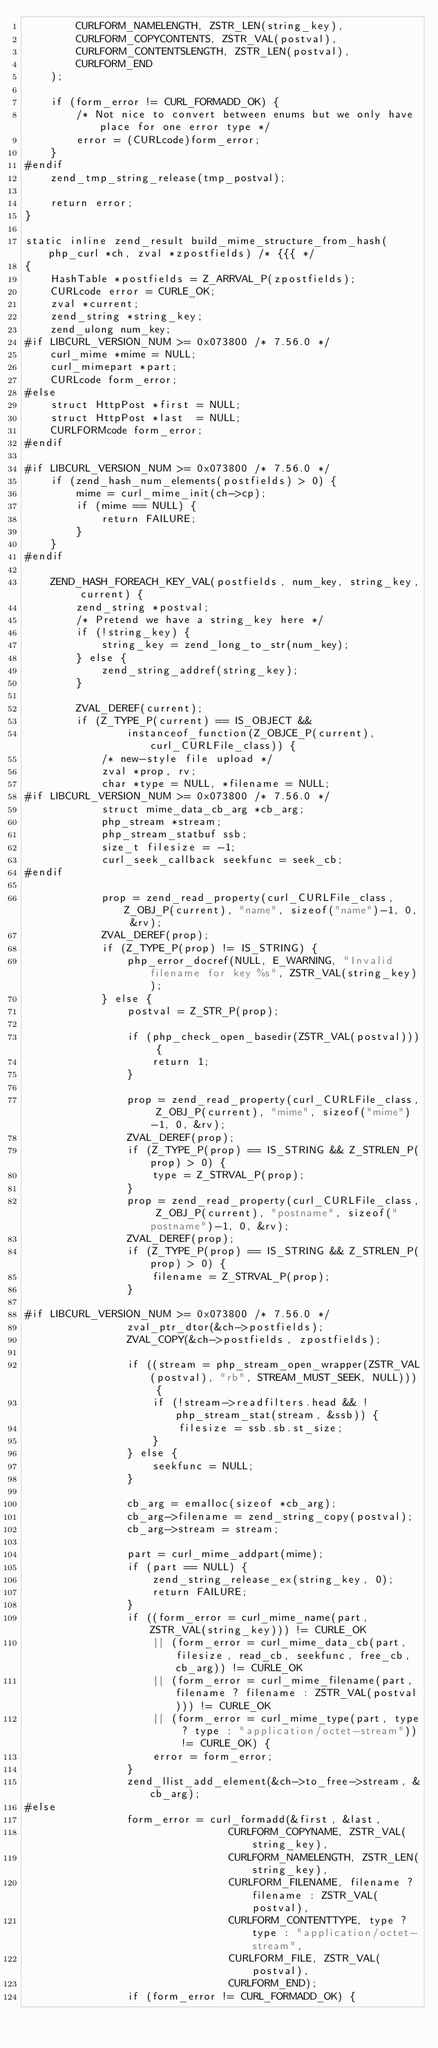<code> <loc_0><loc_0><loc_500><loc_500><_C_>		CURLFORM_NAMELENGTH, ZSTR_LEN(string_key),
		CURLFORM_COPYCONTENTS, ZSTR_VAL(postval),
		CURLFORM_CONTENTSLENGTH, ZSTR_LEN(postval),
		CURLFORM_END
	);

	if (form_error != CURL_FORMADD_OK) {
		/* Not nice to convert between enums but we only have place for one error type */
		error = (CURLcode)form_error;
	}
#endif
	zend_tmp_string_release(tmp_postval);

	return error;
}

static inline zend_result build_mime_structure_from_hash(php_curl *ch, zval *zpostfields) /* {{{ */
{
	HashTable *postfields = Z_ARRVAL_P(zpostfields);
	CURLcode error = CURLE_OK;
	zval *current;
	zend_string *string_key;
	zend_ulong num_key;
#if LIBCURL_VERSION_NUM >= 0x073800 /* 7.56.0 */
	curl_mime *mime = NULL;
	curl_mimepart *part;
	CURLcode form_error;
#else
	struct HttpPost *first = NULL;
	struct HttpPost *last  = NULL;
	CURLFORMcode form_error;
#endif

#if LIBCURL_VERSION_NUM >= 0x073800 /* 7.56.0 */
	if (zend_hash_num_elements(postfields) > 0) {
		mime = curl_mime_init(ch->cp);
		if (mime == NULL) {
			return FAILURE;
		}
	}
#endif

	ZEND_HASH_FOREACH_KEY_VAL(postfields, num_key, string_key, current) {
		zend_string *postval;
		/* Pretend we have a string_key here */
		if (!string_key) {
			string_key = zend_long_to_str(num_key);
		} else {
			zend_string_addref(string_key);
		}

		ZVAL_DEREF(current);
		if (Z_TYPE_P(current) == IS_OBJECT &&
				instanceof_function(Z_OBJCE_P(current), curl_CURLFile_class)) {
			/* new-style file upload */
			zval *prop, rv;
			char *type = NULL, *filename = NULL;
#if LIBCURL_VERSION_NUM >= 0x073800 /* 7.56.0 */
			struct mime_data_cb_arg *cb_arg;
			php_stream *stream;
			php_stream_statbuf ssb;
			size_t filesize = -1;
			curl_seek_callback seekfunc = seek_cb;
#endif

			prop = zend_read_property(curl_CURLFile_class, Z_OBJ_P(current), "name", sizeof("name")-1, 0, &rv);
			ZVAL_DEREF(prop);
			if (Z_TYPE_P(prop) != IS_STRING) {
				php_error_docref(NULL, E_WARNING, "Invalid filename for key %s", ZSTR_VAL(string_key));
			} else {
				postval = Z_STR_P(prop);

				if (php_check_open_basedir(ZSTR_VAL(postval))) {
					return 1;
				}

				prop = zend_read_property(curl_CURLFile_class, Z_OBJ_P(current), "mime", sizeof("mime")-1, 0, &rv);
				ZVAL_DEREF(prop);
				if (Z_TYPE_P(prop) == IS_STRING && Z_STRLEN_P(prop) > 0) {
					type = Z_STRVAL_P(prop);
				}
				prop = zend_read_property(curl_CURLFile_class, Z_OBJ_P(current), "postname", sizeof("postname")-1, 0, &rv);
				ZVAL_DEREF(prop);
				if (Z_TYPE_P(prop) == IS_STRING && Z_STRLEN_P(prop) > 0) {
					filename = Z_STRVAL_P(prop);
				}

#if LIBCURL_VERSION_NUM >= 0x073800 /* 7.56.0 */
				zval_ptr_dtor(&ch->postfields);
				ZVAL_COPY(&ch->postfields, zpostfields);

				if ((stream = php_stream_open_wrapper(ZSTR_VAL(postval), "rb", STREAM_MUST_SEEK, NULL))) {
					if (!stream->readfilters.head && !php_stream_stat(stream, &ssb)) {
						filesize = ssb.sb.st_size;
					}
				} else {
					seekfunc = NULL;
				}

				cb_arg = emalloc(sizeof *cb_arg);
				cb_arg->filename = zend_string_copy(postval);
				cb_arg->stream = stream;

				part = curl_mime_addpart(mime);
				if (part == NULL) {
					zend_string_release_ex(string_key, 0);
					return FAILURE;
				}
				if ((form_error = curl_mime_name(part, ZSTR_VAL(string_key))) != CURLE_OK
					|| (form_error = curl_mime_data_cb(part, filesize, read_cb, seekfunc, free_cb, cb_arg)) != CURLE_OK
					|| (form_error = curl_mime_filename(part, filename ? filename : ZSTR_VAL(postval))) != CURLE_OK
					|| (form_error = curl_mime_type(part, type ? type : "application/octet-stream")) != CURLE_OK) {
					error = form_error;
				}
				zend_llist_add_element(&ch->to_free->stream, &cb_arg);
#else
				form_error = curl_formadd(&first, &last,
								CURLFORM_COPYNAME, ZSTR_VAL(string_key),
								CURLFORM_NAMELENGTH, ZSTR_LEN(string_key),
								CURLFORM_FILENAME, filename ? filename : ZSTR_VAL(postval),
								CURLFORM_CONTENTTYPE, type ? type : "application/octet-stream",
								CURLFORM_FILE, ZSTR_VAL(postval),
								CURLFORM_END);
				if (form_error != CURL_FORMADD_OK) {</code> 